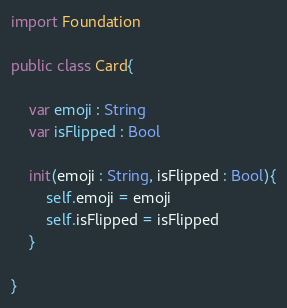Convert code to text. <code><loc_0><loc_0><loc_500><loc_500><_Swift_>
import Foundation

public class Card{
    
    var emoji : String
    var isFlipped : Bool
    
    init(emoji : String, isFlipped : Bool){
        self.emoji = emoji
        self.isFlipped = isFlipped
    }
    
}
</code> 